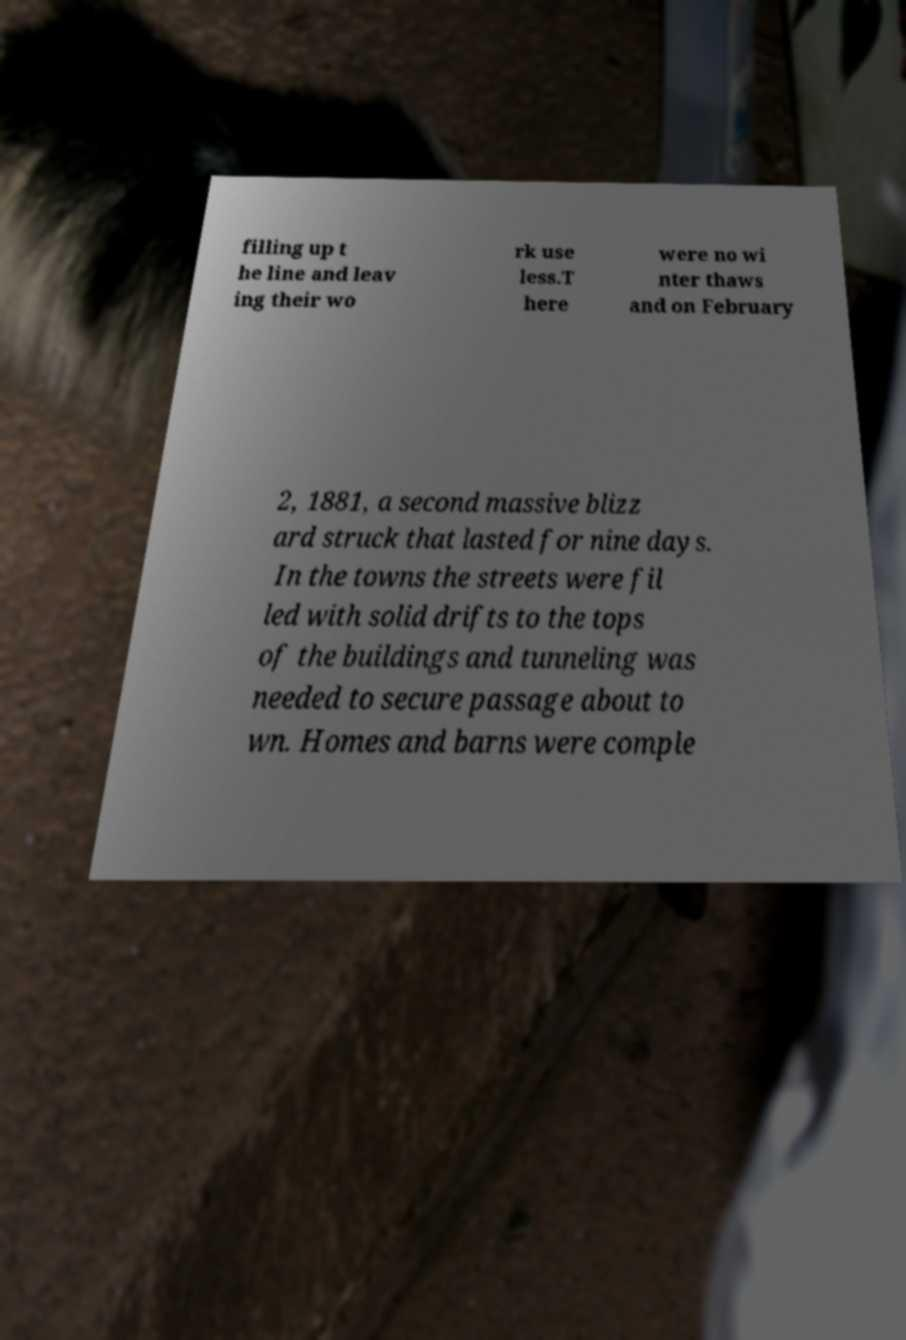There's text embedded in this image that I need extracted. Can you transcribe it verbatim? filling up t he line and leav ing their wo rk use less.T here were no wi nter thaws and on February 2, 1881, a second massive blizz ard struck that lasted for nine days. In the towns the streets were fil led with solid drifts to the tops of the buildings and tunneling was needed to secure passage about to wn. Homes and barns were comple 